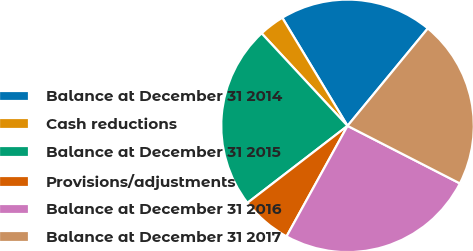Convert chart to OTSL. <chart><loc_0><loc_0><loc_500><loc_500><pie_chart><fcel>Balance at December 31 2014<fcel>Cash reductions<fcel>Balance at December 31 2015<fcel>Provisions/adjustments<fcel>Balance at December 31 2016<fcel>Balance at December 31 2017<nl><fcel>19.61%<fcel>3.27%<fcel>23.53%<fcel>6.54%<fcel>25.49%<fcel>21.57%<nl></chart> 